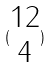Convert formula to latex. <formula><loc_0><loc_0><loc_500><loc_500>( \begin{matrix} 1 2 \\ 4 \end{matrix} )</formula> 